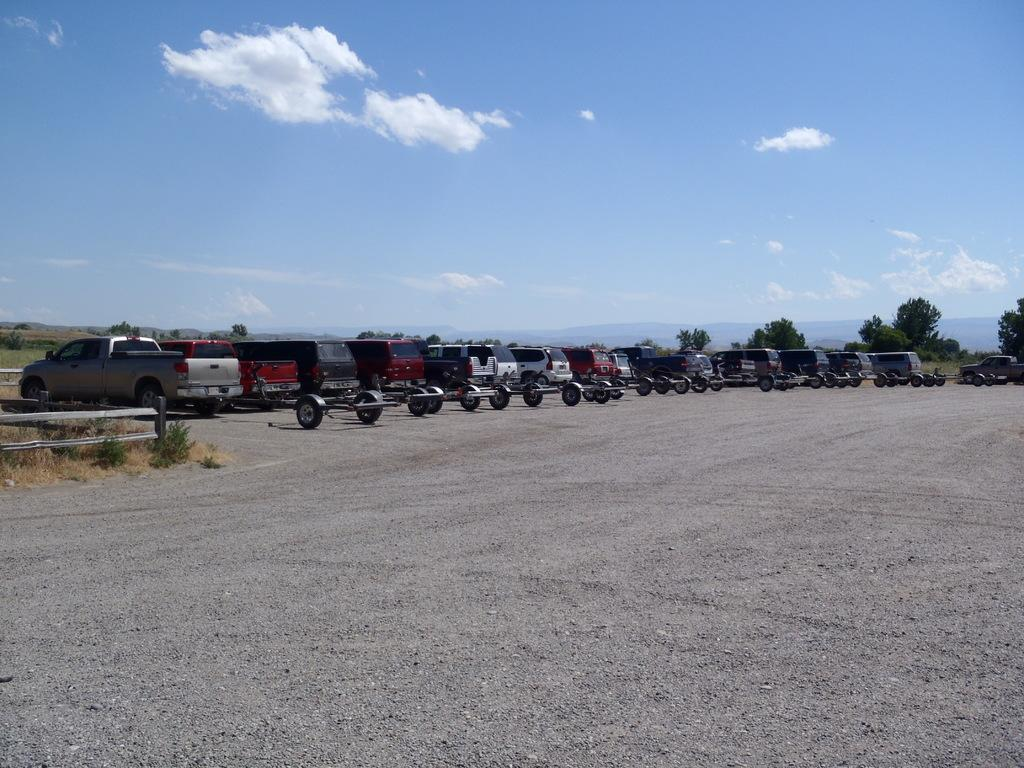What is located on the ground in the image? There is a vehicle on the ground in the image. What can be seen in the background of the image? There are trees, mountains, and the sky visible in the background of the image. What is the condition of the sky in the image? Clouds are present in the sky in the image. How many chickens are perched on the vehicle in the image? There are no chickens present in the image; it only features a vehicle, trees, mountains, and the sky. What type of badge is attached to the vehicle in the image? There is no badge visible on the vehicle in the image. 